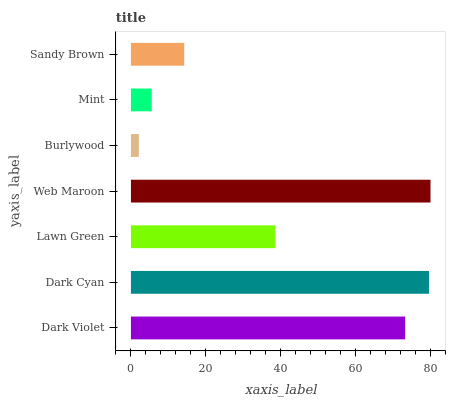Is Burlywood the minimum?
Answer yes or no. Yes. Is Web Maroon the maximum?
Answer yes or no. Yes. Is Dark Cyan the minimum?
Answer yes or no. No. Is Dark Cyan the maximum?
Answer yes or no. No. Is Dark Cyan greater than Dark Violet?
Answer yes or no. Yes. Is Dark Violet less than Dark Cyan?
Answer yes or no. Yes. Is Dark Violet greater than Dark Cyan?
Answer yes or no. No. Is Dark Cyan less than Dark Violet?
Answer yes or no. No. Is Lawn Green the high median?
Answer yes or no. Yes. Is Lawn Green the low median?
Answer yes or no. Yes. Is Web Maroon the high median?
Answer yes or no. No. Is Burlywood the low median?
Answer yes or no. No. 